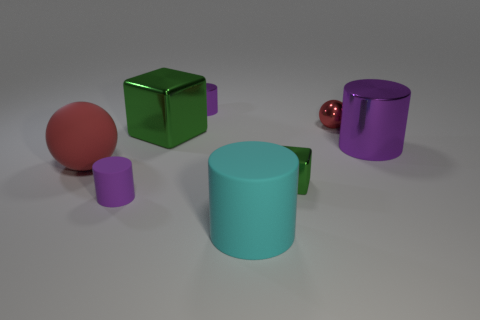What shape is the green thing on the right side of the large cube?
Your answer should be very brief. Cube. What shape is the rubber object behind the tiny purple object that is to the left of the small shiny object left of the tiny green thing?
Offer a very short reply. Sphere. What number of objects are tiny red metallic spheres or tiny rubber cylinders?
Provide a short and direct response. 2. Does the big object to the right of the small red metal object have the same shape as the tiny purple thing behind the big metallic block?
Your answer should be very brief. Yes. What number of tiny things are on the left side of the cyan rubber cylinder and in front of the large matte sphere?
Your answer should be compact. 1. How many other objects are there of the same size as the red metal sphere?
Ensure brevity in your answer.  3. There is a big object that is behind the tiny green block and in front of the large purple metallic object; what is its material?
Give a very brief answer. Rubber. There is a tiny metallic cube; is its color the same as the block that is behind the small green cube?
Your response must be concise. Yes. What size is the other rubber thing that is the same shape as the cyan thing?
Make the answer very short. Small. There is a purple thing that is in front of the small red metal thing and behind the small rubber thing; what is its shape?
Give a very brief answer. Cylinder. 